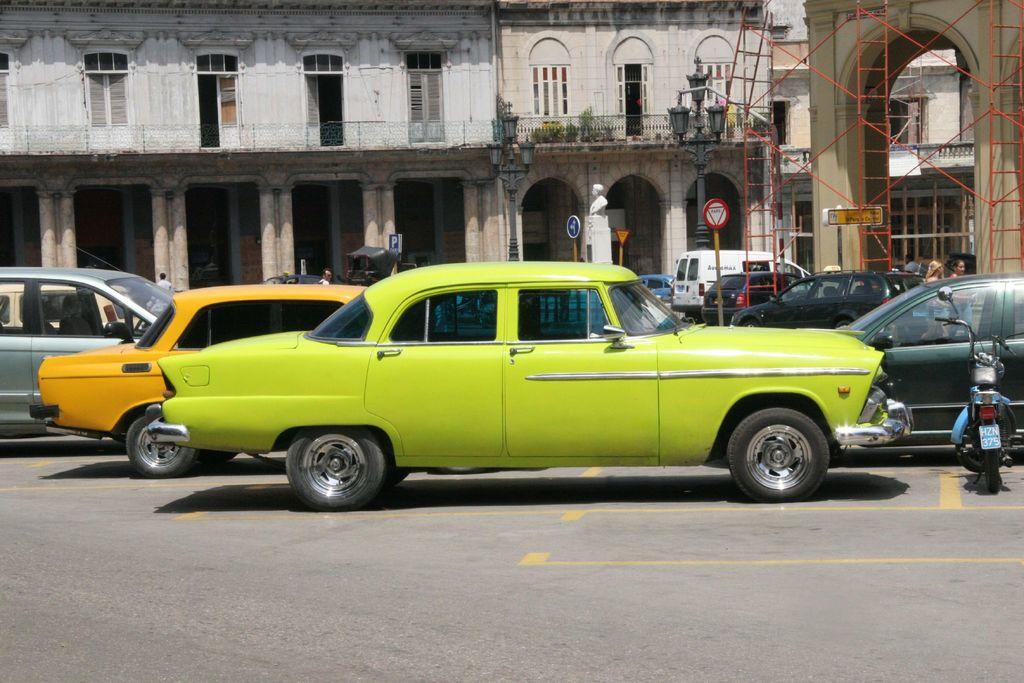What number can be seen on the moped's license palte?
Your response must be concise. 375. What letter is on the blue sign above the yellow car?
Give a very brief answer. P. 